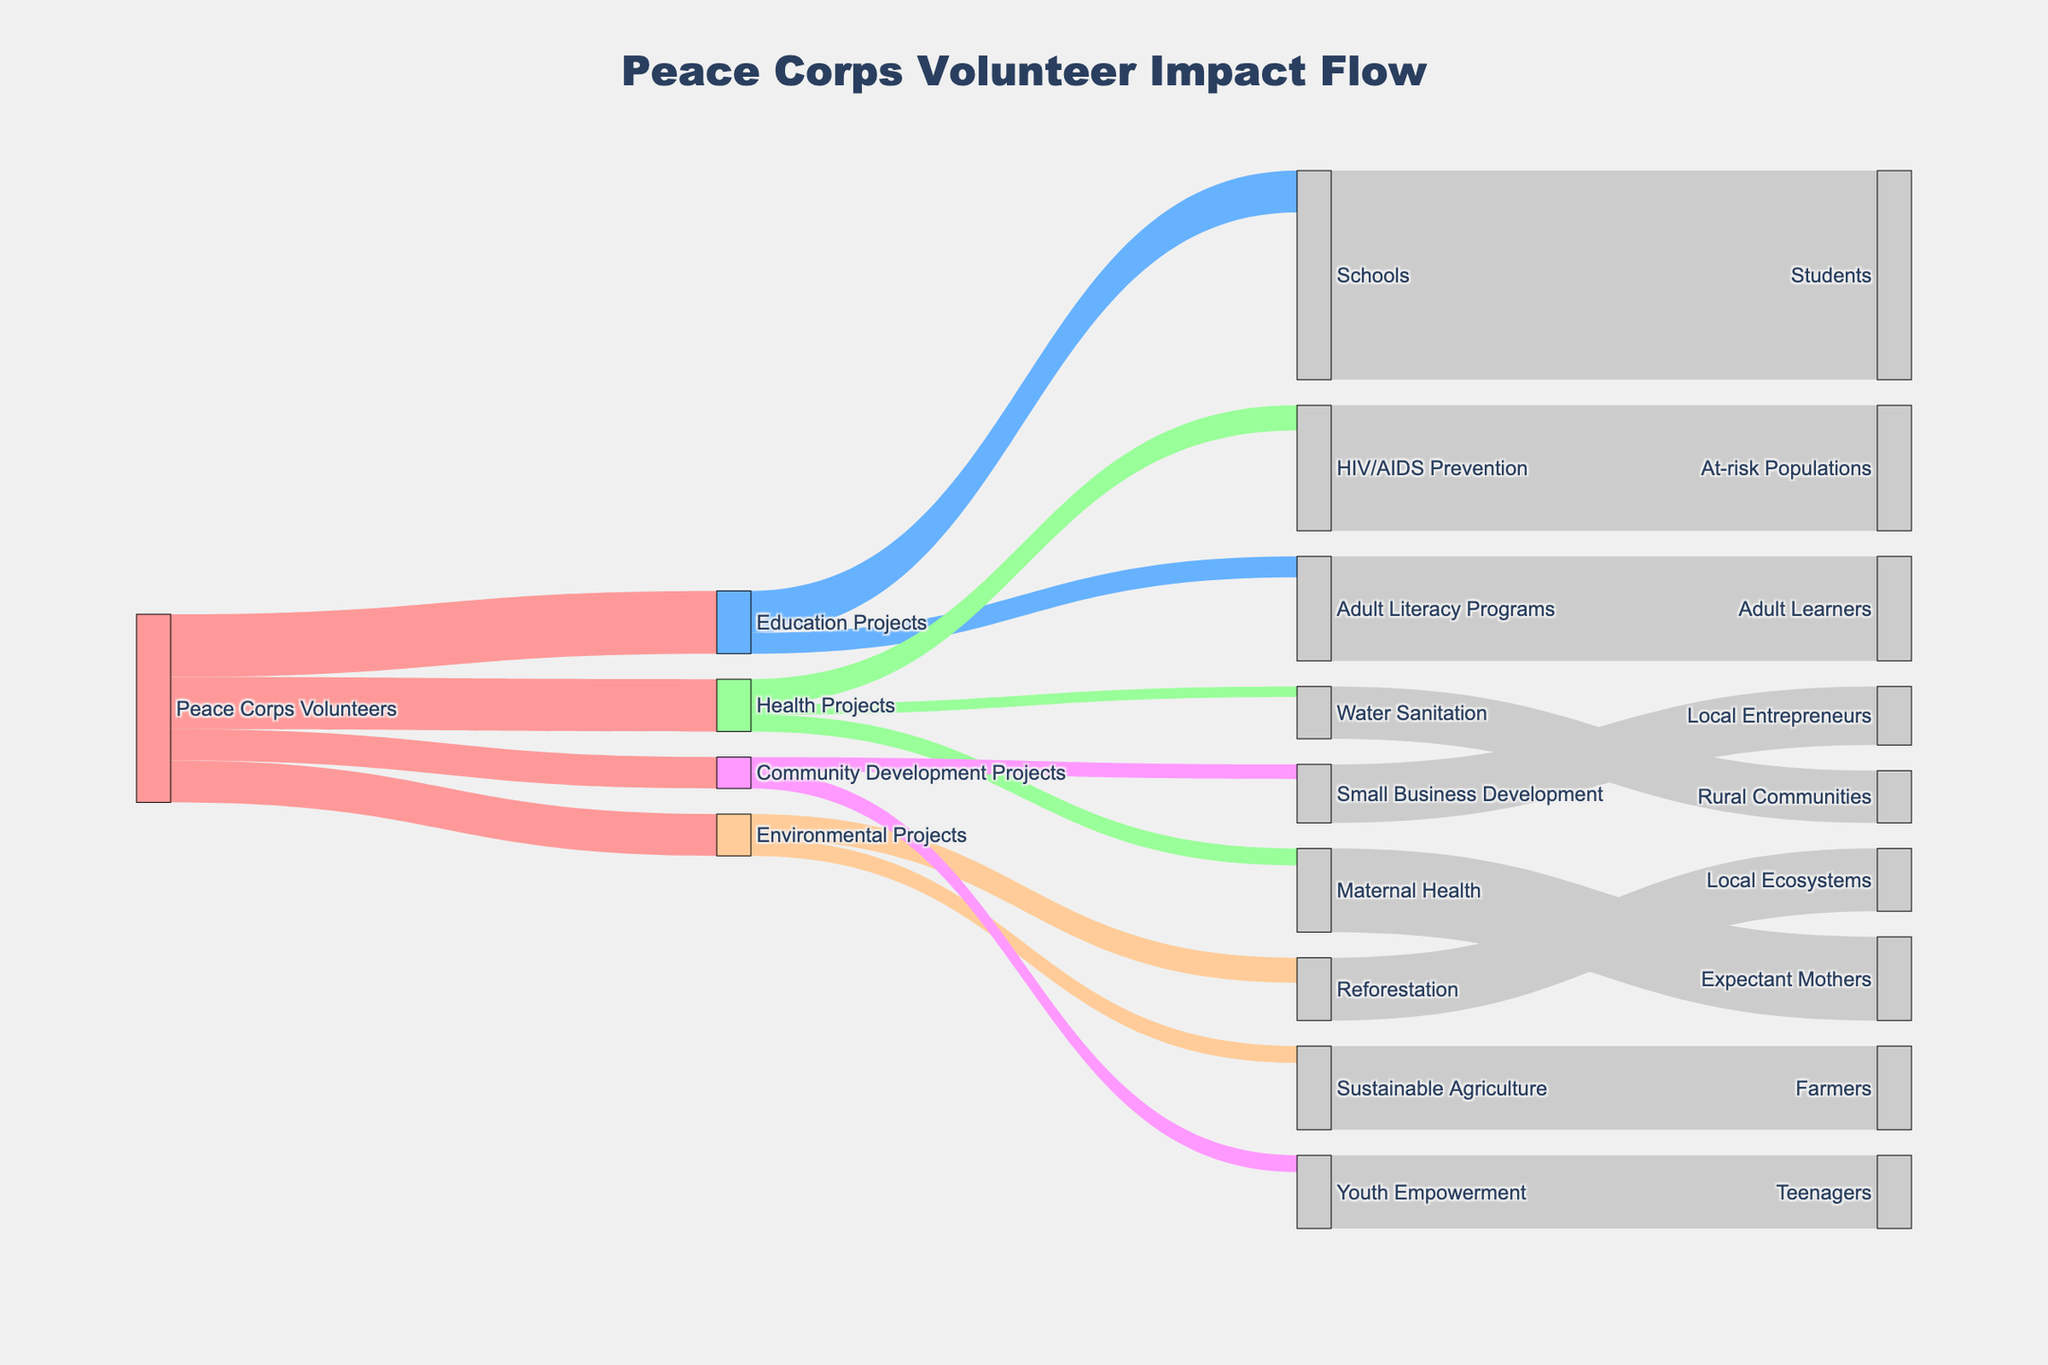What is the title of the figure? The title is located at the top of the plot and provides an overview of what the figure represents. It reads "Peace Corps Volunteer Impact Flow"
Answer: Peace Corps Volunteer Impact Flow What is the largest category of projects that Peace Corps Volunteers are involved in? To determine this, look at the values associated with each project type as sourced from "Peace Corps Volunteers." The largest value is 3000, which corresponds to "Education Projects"
Answer: Education Projects How many total beneficiaries are impacted by Education Projects? Sum the values of the targets of "Education Projects." The targets are "Schools" with 2000 and "Adult Literacy Programs" with 1000. So, the total = 2000 + 1000 = 3000
Answer: 3000 Which specific project within Health Projects impacts the most beneficiaries? Look at the values associated with targets under "Health Projects." The highest value is 1200 for "HIV/AIDS Prevention" which impacts "At-risk Populations"
Answer: HIV/AIDS Prevention Compare the number of beneficiaries impacted by Reforestation to those impacted by Sustainable Agriculture. Which is greater? Look at the values associated with the targets "Reforestation" and "Sustainable Agriculture." Reforestation impacts 3000 beneficiaries, whereas Sustainable Agriculture impacts 4000. Therefore, Sustainable Agriculture is greater
Answer: Sustainable Agriculture How many volunteers are working on projects that have an impact on Local Entrepreneurs? Identify the project targeting "Local Entrepreneurs" which is "Small Business Development" within "Community Development Projects." Then see how many volunteers are involved in Community Development Projects, which is 1500. Therefore, 1500 volunteers are involved
Answer: 1500 What is the main color used for Peace Corps Volunteers? Look at the color providing visual identification for "Peace Corps Volunteers" in the plot, which is a shade of red/pink
Answer: Red/Pink Which project category has the smallest number of volunteers? To determine the smallest number, compare the volunteer counts for each project category. "Community Development Projects" has the smallest value with 1500
Answer: Community Development Projects How many total volunteers are involved in all projects combined? Sum the values for all project categories sourced from "Peace Corps Volunteers": 3000 (Education) + 2500 (Health) + 2000 (Environmental) + 1500 (Community Development) = 9000
Answer: 9000 What is the relationship between "Youth Empowerment" and its beneficiaries in the diagram? "Youth Empowerment" is categorized under "Community Development Projects" and impacts "Teenagers" as beneficiaries, with 800 directed towards Youth Empowerment and 3500 Teenagers impacted
Answer: Community Development Projects impacting Teenagers 